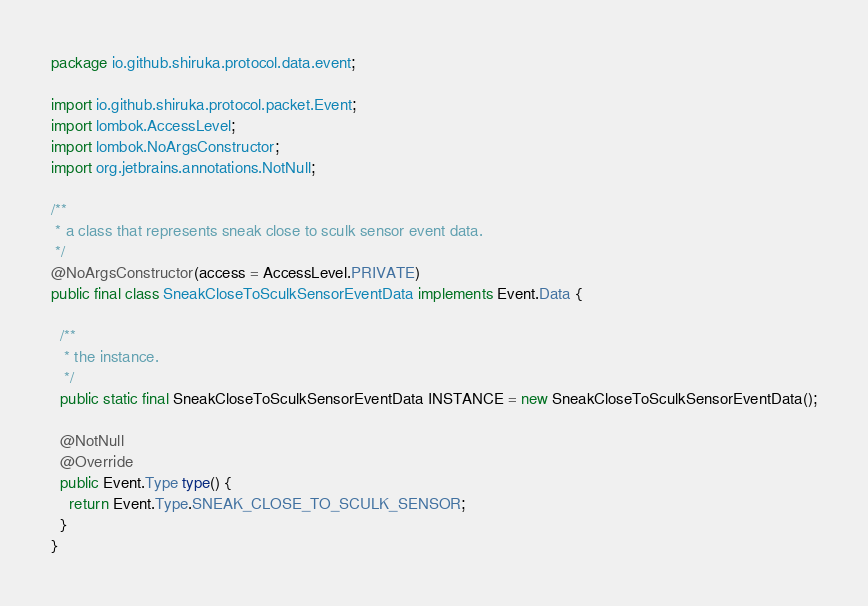<code> <loc_0><loc_0><loc_500><loc_500><_Java_>package io.github.shiruka.protocol.data.event;

import io.github.shiruka.protocol.packet.Event;
import lombok.AccessLevel;
import lombok.NoArgsConstructor;
import org.jetbrains.annotations.NotNull;

/**
 * a class that represents sneak close to sculk sensor event data.
 */
@NoArgsConstructor(access = AccessLevel.PRIVATE)
public final class SneakCloseToSculkSensorEventData implements Event.Data {

  /**
   * the instance.
   */
  public static final SneakCloseToSculkSensorEventData INSTANCE = new SneakCloseToSculkSensorEventData();

  @NotNull
  @Override
  public Event.Type type() {
    return Event.Type.SNEAK_CLOSE_TO_SCULK_SENSOR;
  }
}
</code> 